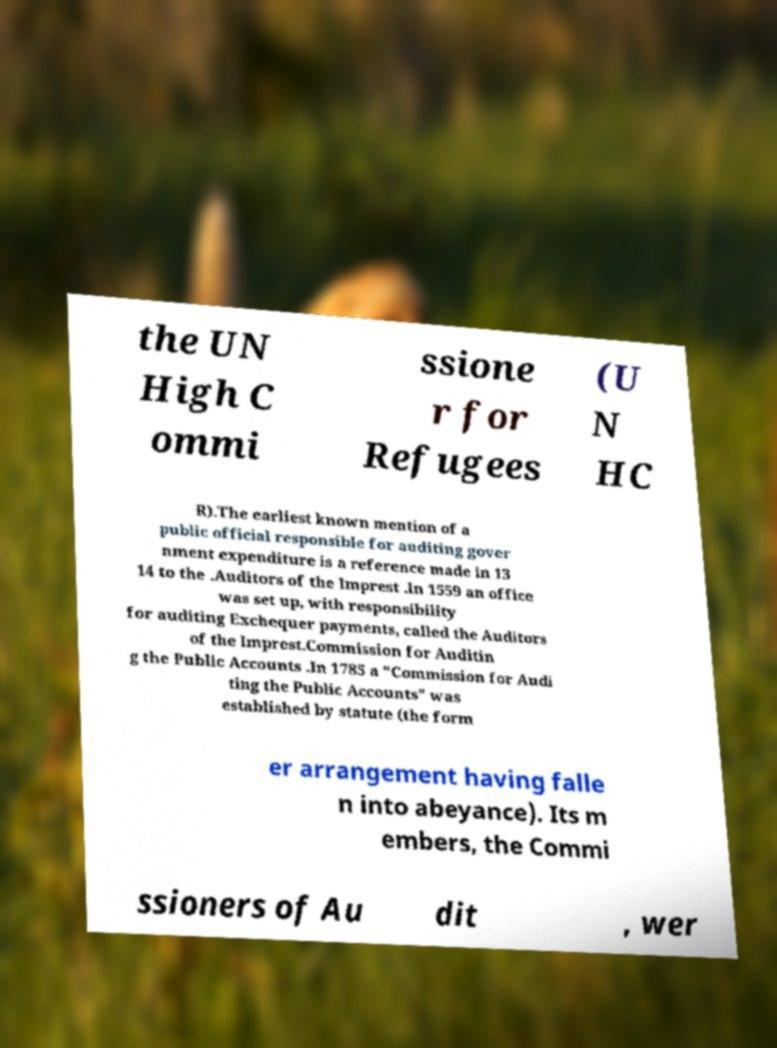What messages or text are displayed in this image? I need them in a readable, typed format. the UN High C ommi ssione r for Refugees (U N HC R).The earliest known mention of a public official responsible for auditing gover nment expenditure is a reference made in 13 14 to the .Auditors of the Imprest .In 1559 an office was set up, with responsibility for auditing Exchequer payments, called the Auditors of the Imprest.Commission for Auditin g the Public Accounts .In 1785 a "Commission for Audi ting the Public Accounts" was established by statute (the form er arrangement having falle n into abeyance). Its m embers, the Commi ssioners of Au dit , wer 